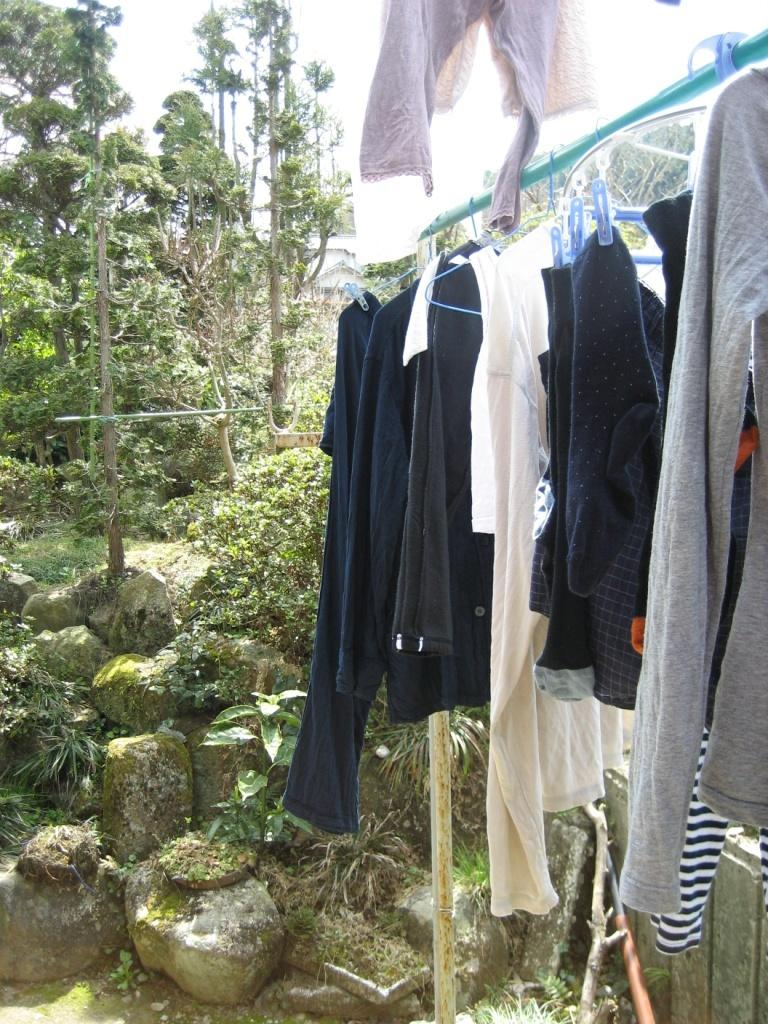What is hanging on the pole on the right side of the image? There are clothes hanged on a pole on the right side of the image. What can be seen in the background of the image? There are trees and rocks in the background of the image. Where is the birth of the newborn baby taking place in the image? There is no indication of a birth or a newborn baby in the image. 